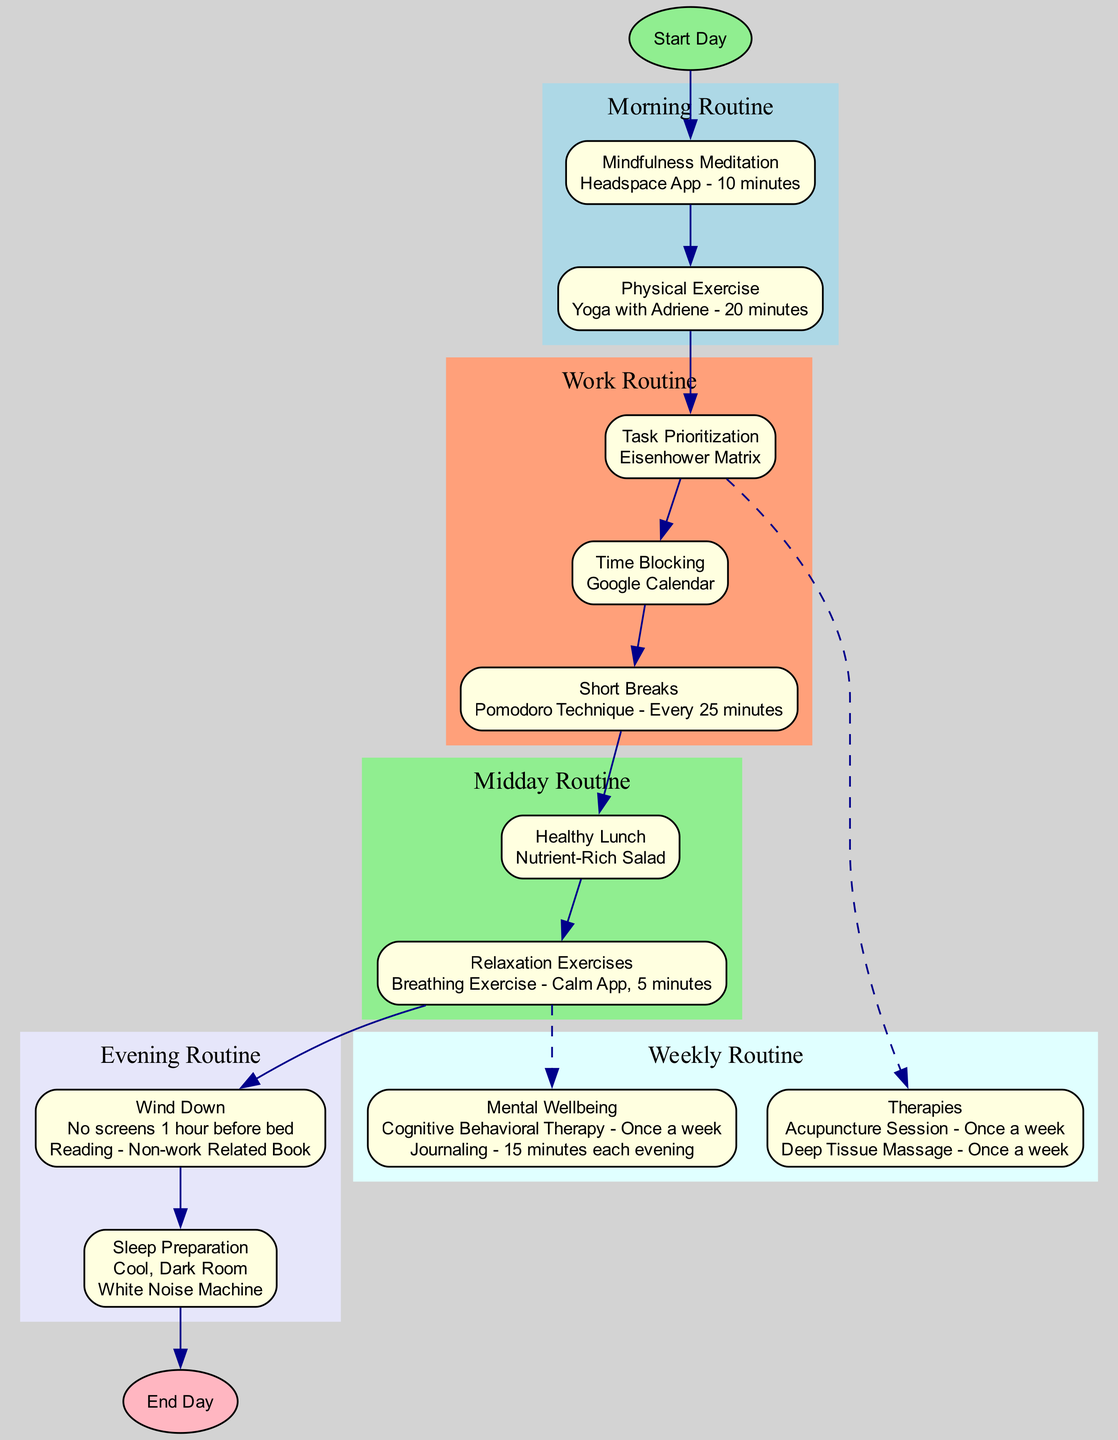What is the first activity in the morning routine? The diagram indicates that the first activity in the morning routine is "Mindfulness Meditation," as it is the first node connected from "Start Day."
Answer: Mindfulness Meditation How long is the physical exercise session? The diagram specifies that the physical exercise session, noted as "Physical Exercise," lasts for "20 minutes," making it clear how much time is dedicated to this activity.
Answer: 20 minutes Which technique is indicated for taking short breaks during work? The diagram states that the technique for taking short breaks is the "Pomodoro Technique - Every 25 minutes," showing how breaks are structured to manage time and stress.
Answer: Pomodoro Technique - Every 25 minutes What type of session occurs weekly for mental wellbeing? According to the diagram, there is a "Cognitive Behavioral Therapy - Once a week" session aimed at mental wellbeing, showing the commitment to ongoing support for stress management.
Answer: Cognitive Behavioral Therapy - Once a week Which two therapies are listed in the weekly routine? The weekly routine node contains "Acupuncture Session - Once a week" and "Deep Tissue Massage - Once a week." You combine these two pieces of information from the Therapies node to answer completely.
Answer: Acupuncture Session - Once a week; Deep Tissue Massage - Once a week What happens after the relaxation exercises in the midday routine? From the diagram, after the "Relaxation Exercises," the next node is "Wind Down," indicating the flow from midday relaxation to evening preparations.
Answer: Wind Down How many main nodes are there in the daily routine? The diagram has three main sections, which are "Start Day," "Evening Routine," and "Weekly Routine," totaling three distinct main nodes in the daily stress management plan.
Answer: Three What is the advised sleeping environment? The diagram specifies "Cool, Dark Room" as the ideal sleep environment for preparing for bed, indicating importance in ensuring good sleep quality.
Answer: Cool, Dark Room What is the last activity before ending the day? The diagram states that the last activity before the day ends is the "Sleep Preparation" activities leading to "End Day," showcasing its role as the conclusion of the stress management routine.
Answer: Sleep Preparation 